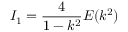<formula> <loc_0><loc_0><loc_500><loc_500>I _ { 1 } = \frac { 4 } { 1 - k ^ { 2 } } E ( k ^ { 2 } )</formula> 